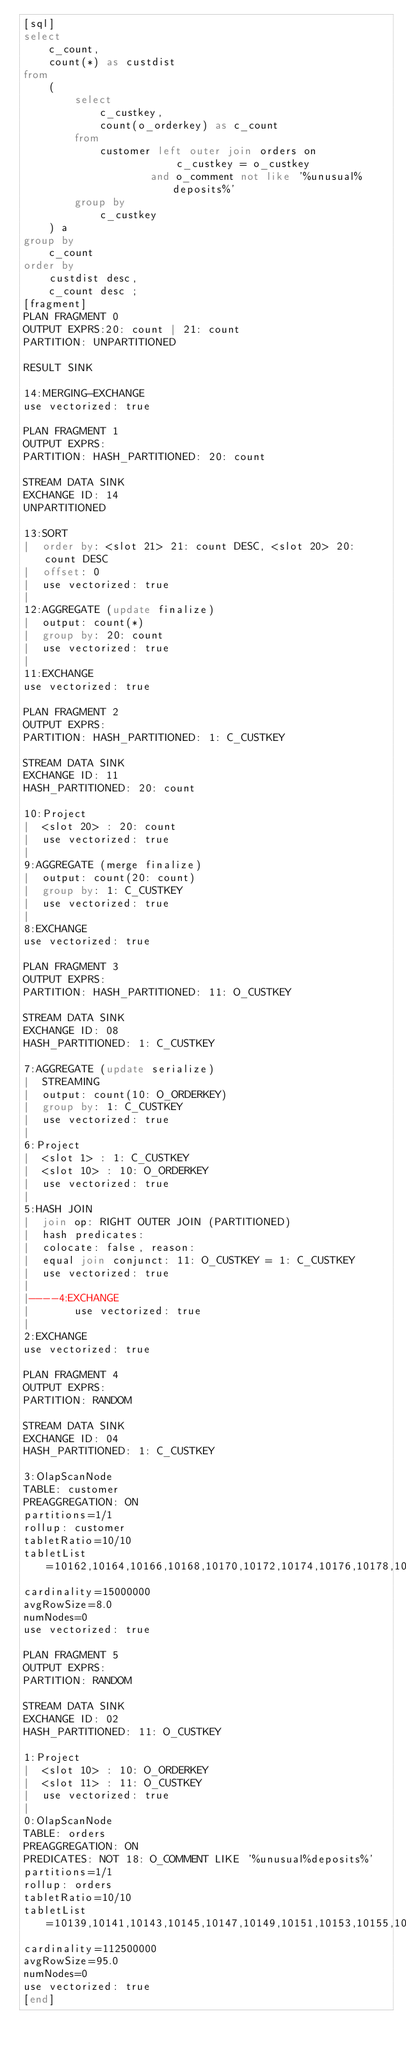<code> <loc_0><loc_0><loc_500><loc_500><_SQL_>[sql]
select
    c_count,
    count(*) as custdist
from
    (
        select
            c_custkey,
            count(o_orderkey) as c_count
        from
            customer left outer join orders on
                        c_custkey = o_custkey
                    and o_comment not like '%unusual%deposits%'
        group by
            c_custkey
    ) a
group by
    c_count
order by
    custdist desc,
    c_count desc ;
[fragment]
PLAN FRAGMENT 0
OUTPUT EXPRS:20: count | 21: count
PARTITION: UNPARTITIONED

RESULT SINK

14:MERGING-EXCHANGE
use vectorized: true

PLAN FRAGMENT 1
OUTPUT EXPRS:
PARTITION: HASH_PARTITIONED: 20: count

STREAM DATA SINK
EXCHANGE ID: 14
UNPARTITIONED

13:SORT
|  order by: <slot 21> 21: count DESC, <slot 20> 20: count DESC
|  offset: 0
|  use vectorized: true
|
12:AGGREGATE (update finalize)
|  output: count(*)
|  group by: 20: count
|  use vectorized: true
|
11:EXCHANGE
use vectorized: true

PLAN FRAGMENT 2
OUTPUT EXPRS:
PARTITION: HASH_PARTITIONED: 1: C_CUSTKEY

STREAM DATA SINK
EXCHANGE ID: 11
HASH_PARTITIONED: 20: count

10:Project
|  <slot 20> : 20: count
|  use vectorized: true
|
9:AGGREGATE (merge finalize)
|  output: count(20: count)
|  group by: 1: C_CUSTKEY
|  use vectorized: true
|
8:EXCHANGE
use vectorized: true

PLAN FRAGMENT 3
OUTPUT EXPRS:
PARTITION: HASH_PARTITIONED: 11: O_CUSTKEY

STREAM DATA SINK
EXCHANGE ID: 08
HASH_PARTITIONED: 1: C_CUSTKEY

7:AGGREGATE (update serialize)
|  STREAMING
|  output: count(10: O_ORDERKEY)
|  group by: 1: C_CUSTKEY
|  use vectorized: true
|
6:Project
|  <slot 1> : 1: C_CUSTKEY
|  <slot 10> : 10: O_ORDERKEY
|  use vectorized: true
|
5:HASH JOIN
|  join op: RIGHT OUTER JOIN (PARTITIONED)
|  hash predicates:
|  colocate: false, reason:
|  equal join conjunct: 11: O_CUSTKEY = 1: C_CUSTKEY
|  use vectorized: true
|
|----4:EXCHANGE
|       use vectorized: true
|
2:EXCHANGE
use vectorized: true

PLAN FRAGMENT 4
OUTPUT EXPRS:
PARTITION: RANDOM

STREAM DATA SINK
EXCHANGE ID: 04
HASH_PARTITIONED: 1: C_CUSTKEY

3:OlapScanNode
TABLE: customer
PREAGGREGATION: ON
partitions=1/1
rollup: customer
tabletRatio=10/10
tabletList=10162,10164,10166,10168,10170,10172,10174,10176,10178,10180
cardinality=15000000
avgRowSize=8.0
numNodes=0
use vectorized: true

PLAN FRAGMENT 5
OUTPUT EXPRS:
PARTITION: RANDOM

STREAM DATA SINK
EXCHANGE ID: 02
HASH_PARTITIONED: 11: O_CUSTKEY

1:Project
|  <slot 10> : 10: O_ORDERKEY
|  <slot 11> : 11: O_CUSTKEY
|  use vectorized: true
|
0:OlapScanNode
TABLE: orders
PREAGGREGATION: ON
PREDICATES: NOT 18: O_COMMENT LIKE '%unusual%deposits%'
partitions=1/1
rollup: orders
tabletRatio=10/10
tabletList=10139,10141,10143,10145,10147,10149,10151,10153,10155,10157
cardinality=112500000
avgRowSize=95.0
numNodes=0
use vectorized: true
[end]

</code> 